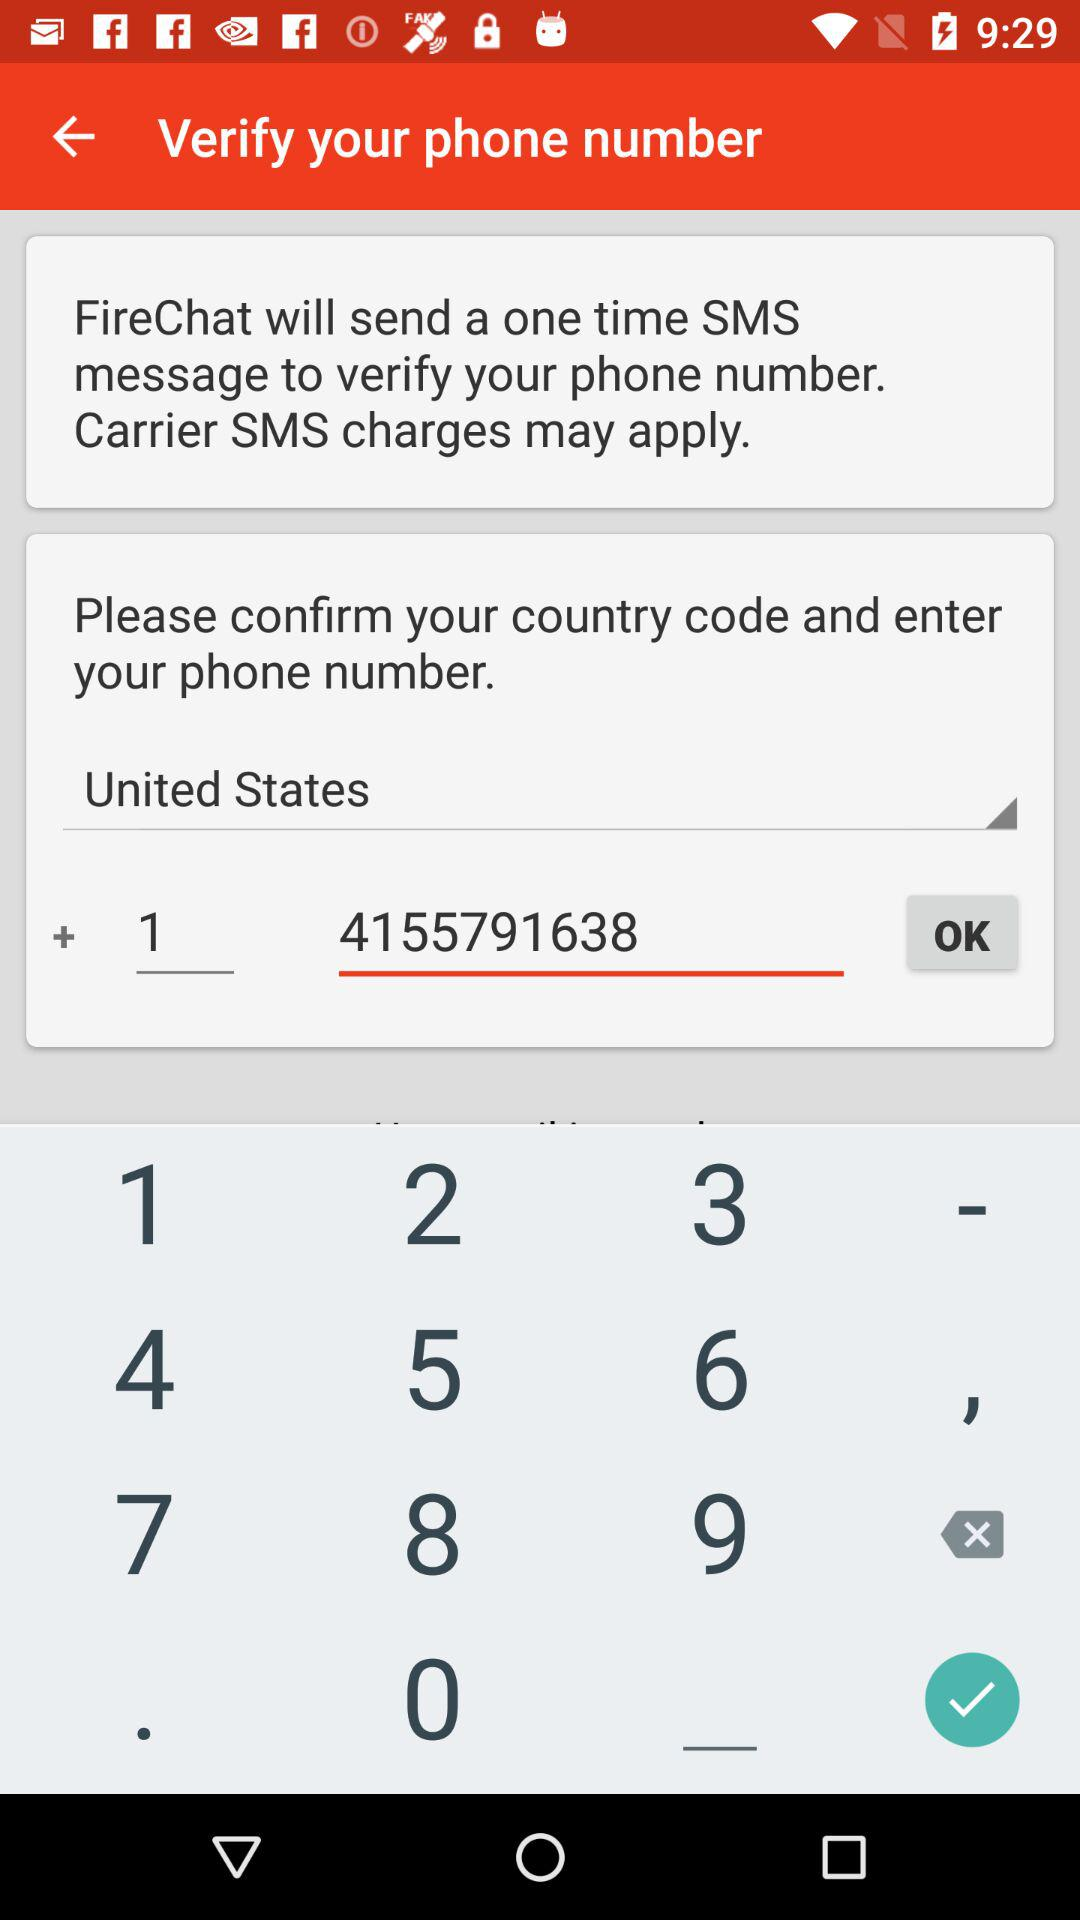Which country is selected for the option? The selected country is the United States. 